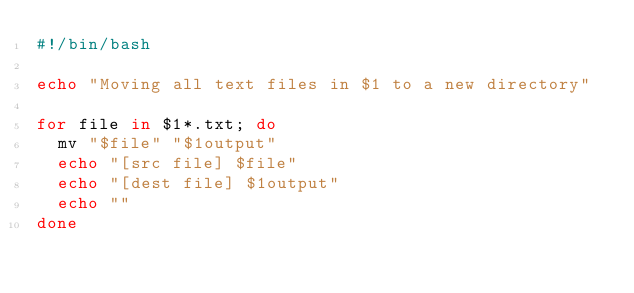Convert code to text. <code><loc_0><loc_0><loc_500><loc_500><_Bash_>#!/bin/bash

echo "Moving all text files in $1 to a new directory"

for file in $1*.txt; do
	mv "$file" "$1output"
	echo "[src file] $file"
	echo "[dest file] $1output"
	echo ""
done</code> 